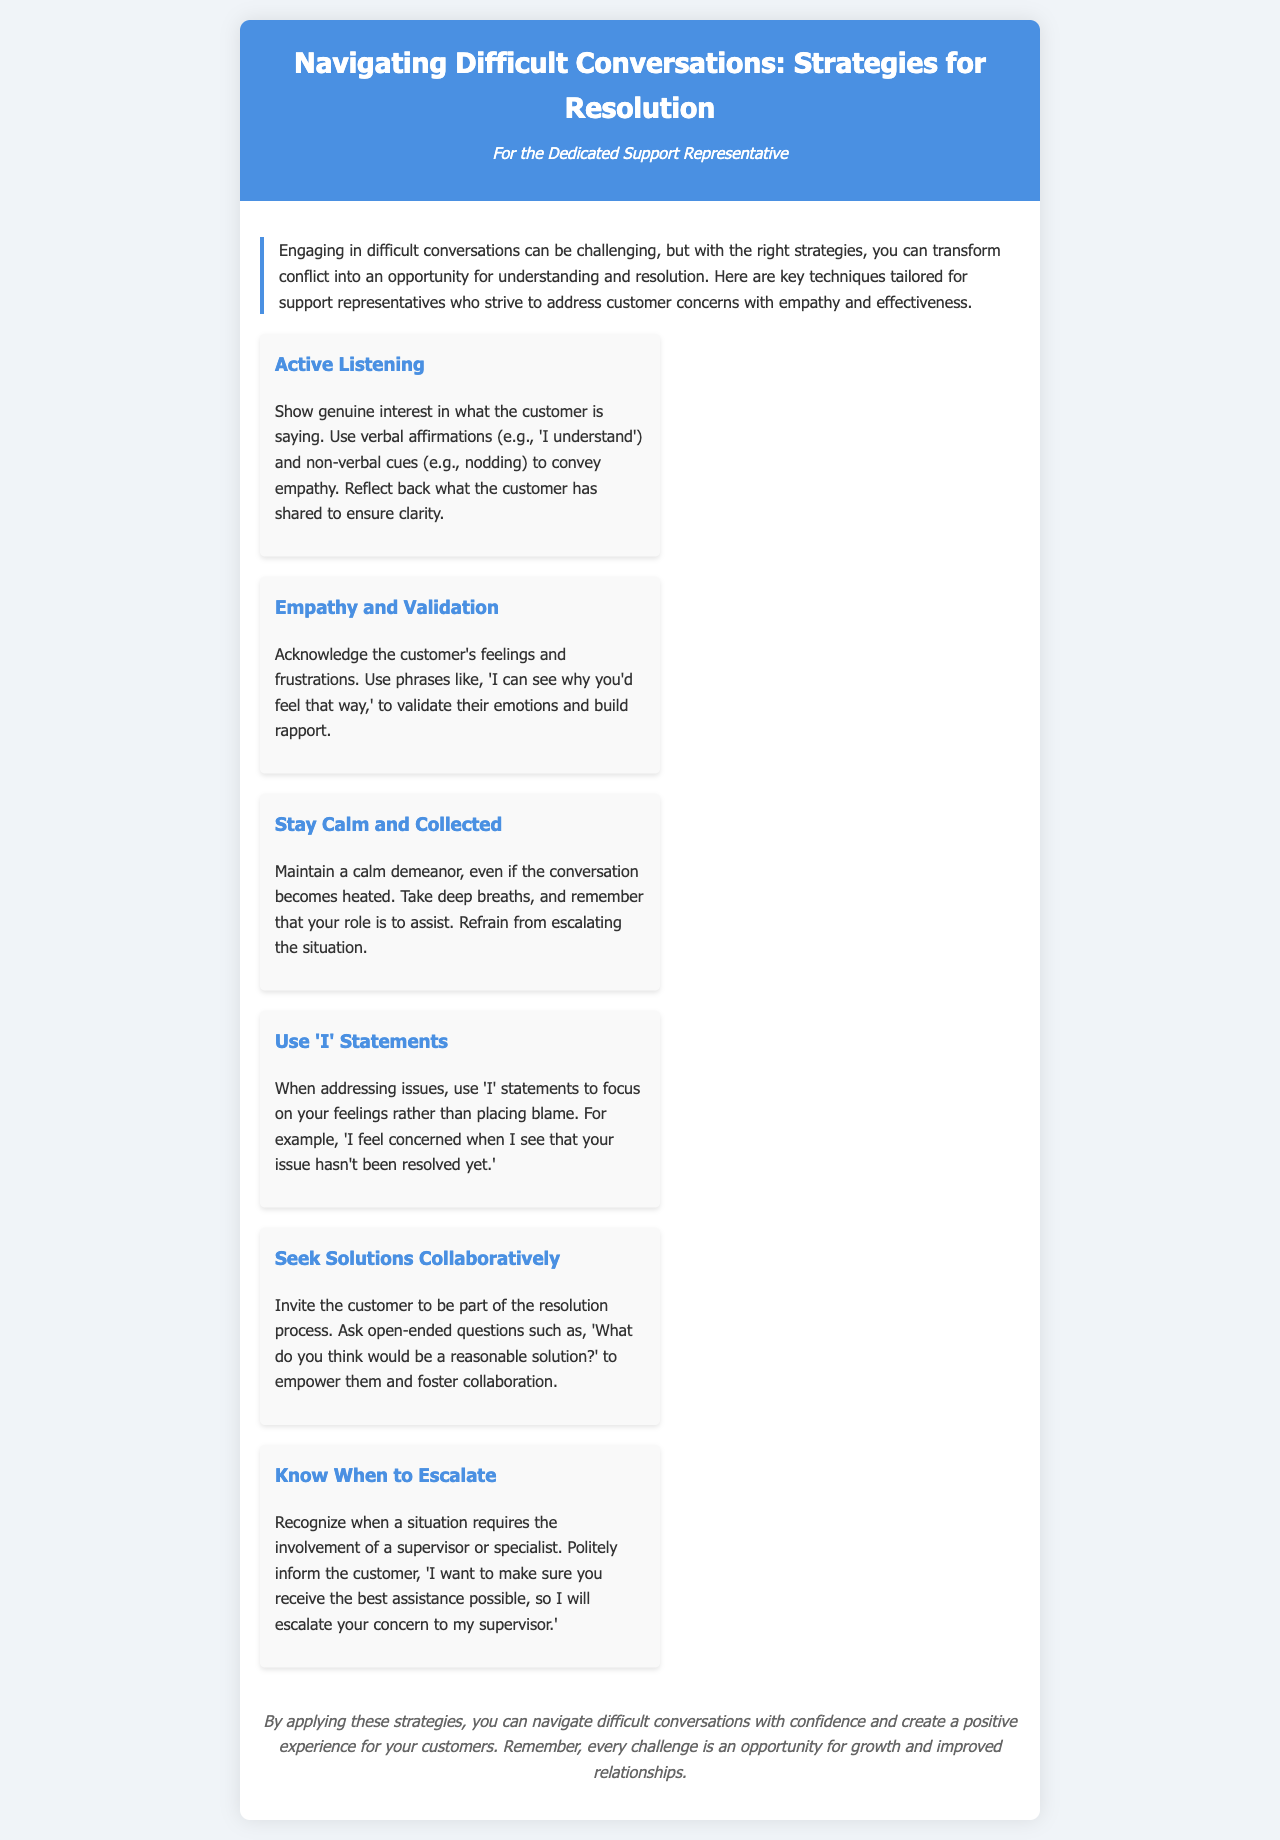what is the title of the brochure? The title is presented prominently at the top of the document in the header section.
Answer: Navigating Difficult Conversations: Strategies for Resolution who is the intended audience of the brochure? The intended audience is indicated in the persona section of the header.
Answer: For the Dedicated Support Representative how many strategies are presented in the brochure? The number of strategies is counted from the listed techniques in the content section.
Answer: Six what strategy emphasizes showing genuine interest? This strategy focuses on active engagement with the customer during conversations.
Answer: Active Listening what phrase is suggested to validate a customer's feelings? The phrase is included under the empathy section to help acknowledge emotions.
Answer: I can see why you'd feel that way what does the brochure advise when a conversation becomes heated? The brochure provides guidance on maintaining composure in challenging situations.
Answer: Stay Calm and Collected which strategy involves collaborative problem-solving? The strategy that encourages inviting the customer to participate in finding solutions.
Answer: Seek Solutions Collaboratively what should you use to focus on your feelings rather than placing blame? This approach is described in the context of addressing issues constructively.
Answer: I statements what does the conclusion suggest about challenges? The conclusion provides a perspective on how to view challenges in conversations.
Answer: An opportunity for growth and improved relationships 